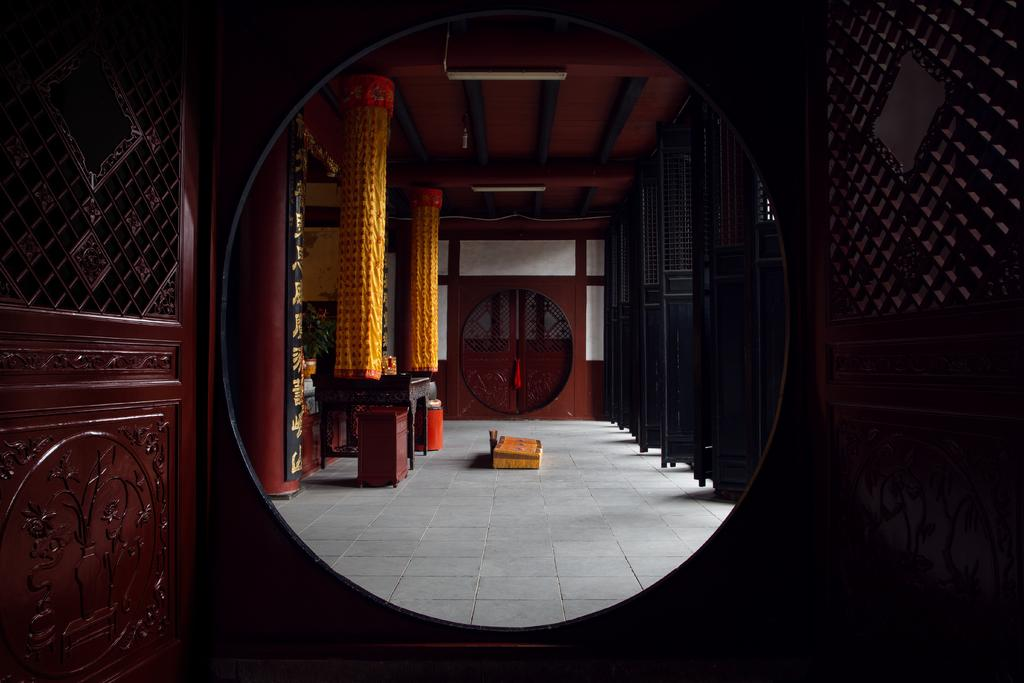What type of location is depicted in the image? The image is an inside view of a room. Where are the doors located in the room? There are doors on the right and left sides of the image. What can be seen in the background of the room? There are two pillars, a table, doors, and stools in the background of the image. What type of book is placed on the zinc table in the image? There is no book or zinc table present in the image. How many leaves are visible on the floor in the image? There are no leaves visible on the floor in the image. 